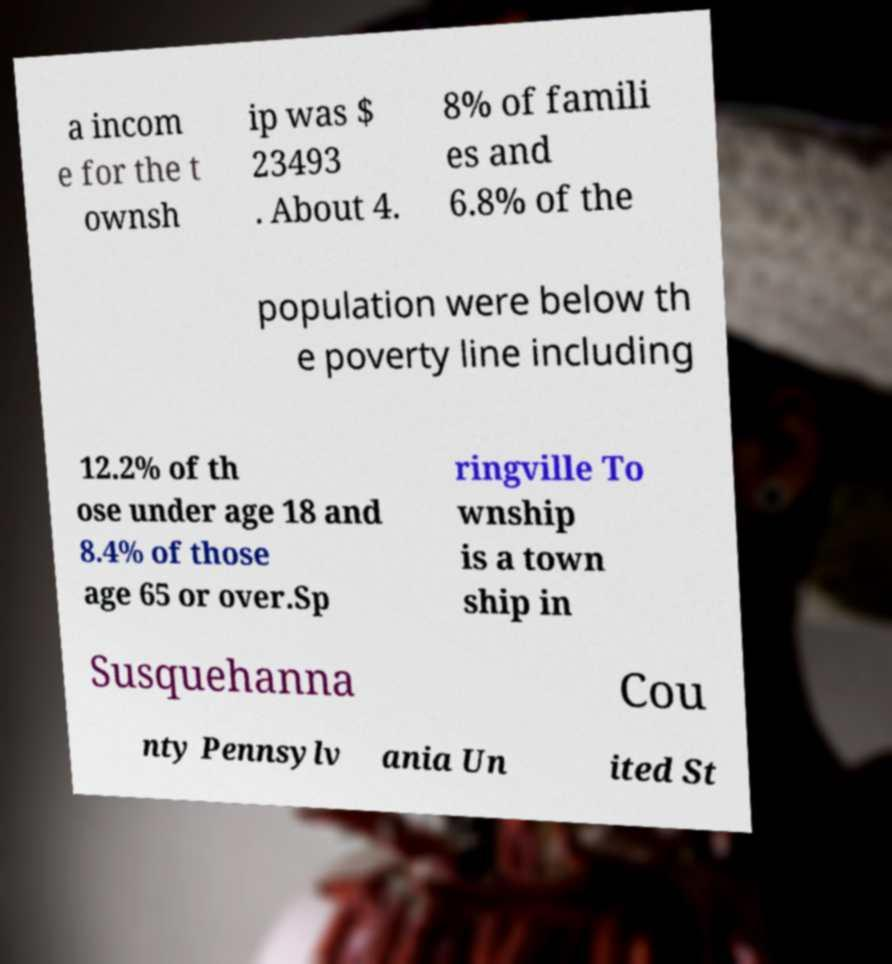There's text embedded in this image that I need extracted. Can you transcribe it verbatim? a incom e for the t ownsh ip was $ 23493 . About 4. 8% of famili es and 6.8% of the population were below th e poverty line including 12.2% of th ose under age 18 and 8.4% of those age 65 or over.Sp ringville To wnship is a town ship in Susquehanna Cou nty Pennsylv ania Un ited St 